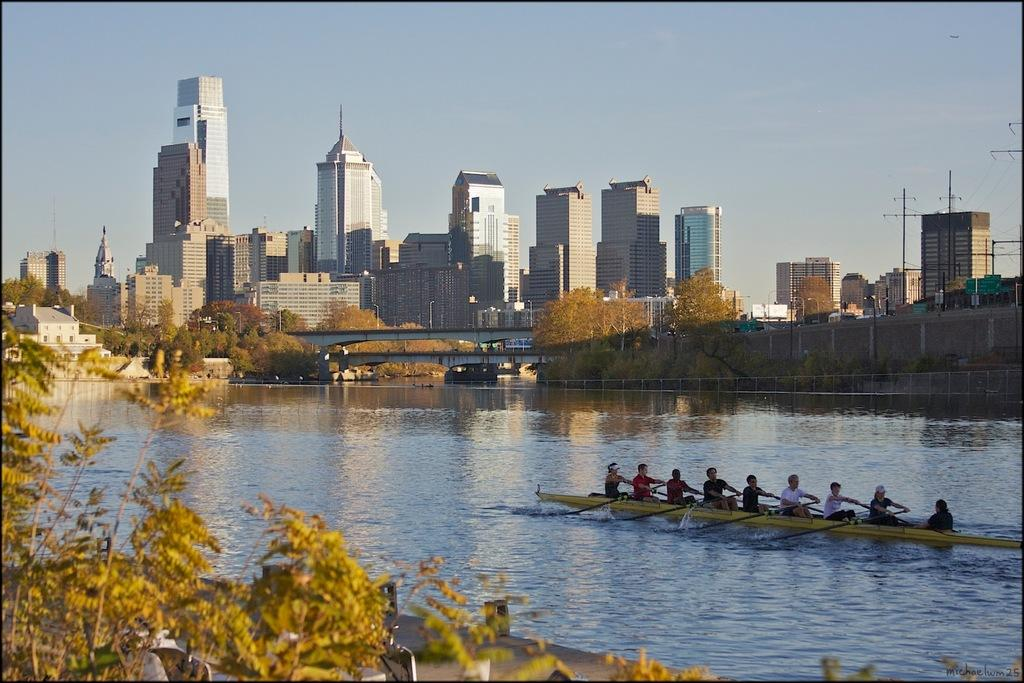What activity are the people in the image engaged in? The people in the image are boating in the water. What type of natural environment can be seen in the image? There are trees visible in the image. What type of structures are present in the image? There are buildings in the image. What type of barrier can be seen in the image? There is fencing in the image. What type of dirt can be seen in the image? There is no dirt visible in the image. What is the reason for the people boating in the image? The image does not provide any information about the reason for the people boating. 